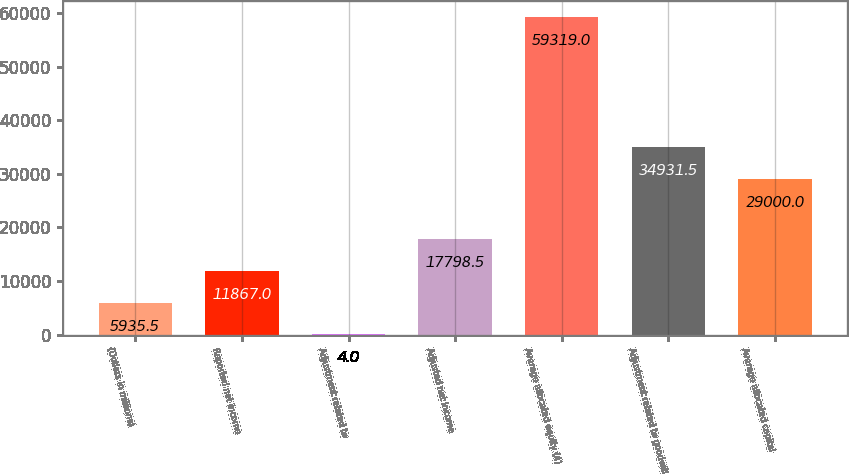Convert chart to OTSL. <chart><loc_0><loc_0><loc_500><loc_500><bar_chart><fcel>(Dollars in millions)<fcel>Reported net income<fcel>Adjustment related to<fcel>Adjusted net income<fcel>Average allocated equity (4)<fcel>Adjustment related to goodwill<fcel>Average allocated capital<nl><fcel>5935.5<fcel>11867<fcel>4<fcel>17798.5<fcel>59319<fcel>34931.5<fcel>29000<nl></chart> 